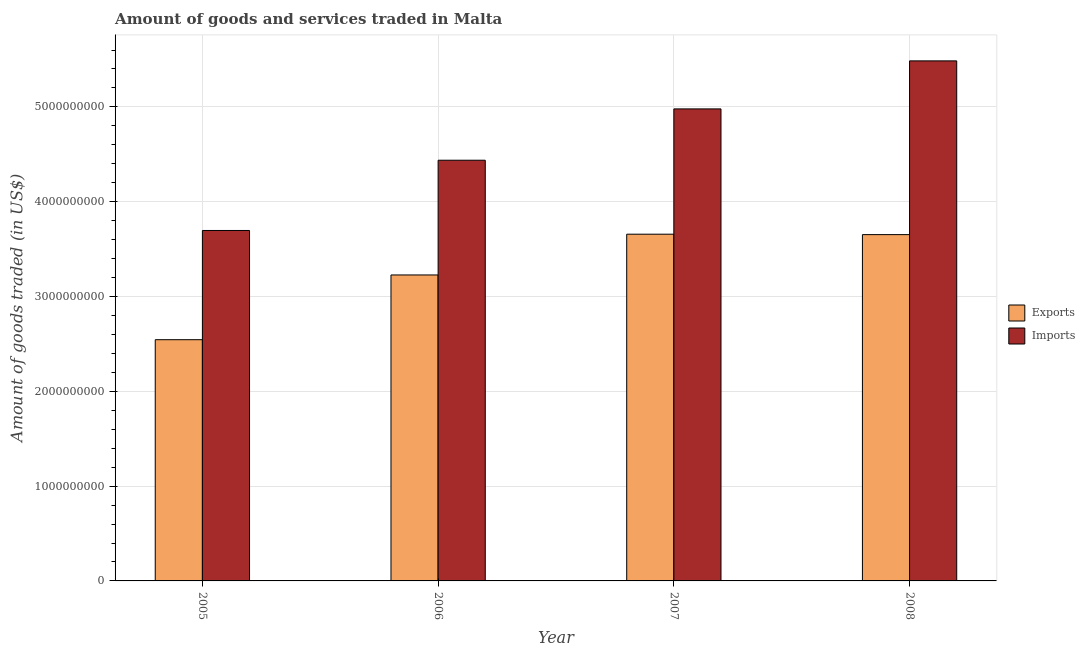How many groups of bars are there?
Your answer should be very brief. 4. Are the number of bars per tick equal to the number of legend labels?
Ensure brevity in your answer.  Yes. Are the number of bars on each tick of the X-axis equal?
Offer a very short reply. Yes. How many bars are there on the 1st tick from the left?
Your answer should be compact. 2. What is the amount of goods exported in 2006?
Ensure brevity in your answer.  3.23e+09. Across all years, what is the maximum amount of goods exported?
Provide a succinct answer. 3.66e+09. Across all years, what is the minimum amount of goods exported?
Offer a very short reply. 2.54e+09. In which year was the amount of goods imported maximum?
Make the answer very short. 2008. In which year was the amount of goods imported minimum?
Give a very brief answer. 2005. What is the total amount of goods exported in the graph?
Offer a terse response. 1.31e+1. What is the difference between the amount of goods imported in 2007 and that in 2008?
Your answer should be compact. -5.07e+08. What is the difference between the amount of goods exported in 2005 and the amount of goods imported in 2008?
Make the answer very short. -1.11e+09. What is the average amount of goods imported per year?
Offer a terse response. 4.65e+09. In the year 2005, what is the difference between the amount of goods exported and amount of goods imported?
Provide a succinct answer. 0. In how many years, is the amount of goods imported greater than 3800000000 US$?
Your answer should be compact. 3. What is the ratio of the amount of goods imported in 2005 to that in 2008?
Your answer should be very brief. 0.67. Is the difference between the amount of goods imported in 2005 and 2006 greater than the difference between the amount of goods exported in 2005 and 2006?
Your answer should be compact. No. What is the difference between the highest and the second highest amount of goods exported?
Offer a very short reply. 4.45e+06. What is the difference between the highest and the lowest amount of goods imported?
Your answer should be compact. 1.79e+09. In how many years, is the amount of goods imported greater than the average amount of goods imported taken over all years?
Keep it short and to the point. 2. Is the sum of the amount of goods exported in 2005 and 2007 greater than the maximum amount of goods imported across all years?
Ensure brevity in your answer.  Yes. What does the 1st bar from the left in 2005 represents?
Make the answer very short. Exports. What does the 1st bar from the right in 2008 represents?
Ensure brevity in your answer.  Imports. How many bars are there?
Your answer should be very brief. 8. Are the values on the major ticks of Y-axis written in scientific E-notation?
Ensure brevity in your answer.  No. Does the graph contain any zero values?
Your answer should be compact. No. Does the graph contain grids?
Make the answer very short. Yes. Where does the legend appear in the graph?
Ensure brevity in your answer.  Center right. What is the title of the graph?
Provide a short and direct response. Amount of goods and services traded in Malta. What is the label or title of the Y-axis?
Ensure brevity in your answer.  Amount of goods traded (in US$). What is the Amount of goods traded (in US$) in Exports in 2005?
Keep it short and to the point. 2.54e+09. What is the Amount of goods traded (in US$) in Imports in 2005?
Ensure brevity in your answer.  3.70e+09. What is the Amount of goods traded (in US$) in Exports in 2006?
Make the answer very short. 3.23e+09. What is the Amount of goods traded (in US$) in Imports in 2006?
Provide a succinct answer. 4.44e+09. What is the Amount of goods traded (in US$) in Exports in 2007?
Keep it short and to the point. 3.66e+09. What is the Amount of goods traded (in US$) of Imports in 2007?
Offer a very short reply. 4.98e+09. What is the Amount of goods traded (in US$) in Exports in 2008?
Provide a short and direct response. 3.65e+09. What is the Amount of goods traded (in US$) in Imports in 2008?
Provide a short and direct response. 5.49e+09. Across all years, what is the maximum Amount of goods traded (in US$) of Exports?
Offer a very short reply. 3.66e+09. Across all years, what is the maximum Amount of goods traded (in US$) of Imports?
Make the answer very short. 5.49e+09. Across all years, what is the minimum Amount of goods traded (in US$) of Exports?
Make the answer very short. 2.54e+09. Across all years, what is the minimum Amount of goods traded (in US$) of Imports?
Your response must be concise. 3.70e+09. What is the total Amount of goods traded (in US$) in Exports in the graph?
Provide a short and direct response. 1.31e+1. What is the total Amount of goods traded (in US$) of Imports in the graph?
Provide a short and direct response. 1.86e+1. What is the difference between the Amount of goods traded (in US$) in Exports in 2005 and that in 2006?
Your response must be concise. -6.83e+08. What is the difference between the Amount of goods traded (in US$) of Imports in 2005 and that in 2006?
Make the answer very short. -7.41e+08. What is the difference between the Amount of goods traded (in US$) in Exports in 2005 and that in 2007?
Keep it short and to the point. -1.11e+09. What is the difference between the Amount of goods traded (in US$) in Imports in 2005 and that in 2007?
Your answer should be compact. -1.28e+09. What is the difference between the Amount of goods traded (in US$) in Exports in 2005 and that in 2008?
Keep it short and to the point. -1.11e+09. What is the difference between the Amount of goods traded (in US$) in Imports in 2005 and that in 2008?
Your answer should be very brief. -1.79e+09. What is the difference between the Amount of goods traded (in US$) of Exports in 2006 and that in 2007?
Provide a short and direct response. -4.30e+08. What is the difference between the Amount of goods traded (in US$) in Imports in 2006 and that in 2007?
Make the answer very short. -5.41e+08. What is the difference between the Amount of goods traded (in US$) of Exports in 2006 and that in 2008?
Provide a succinct answer. -4.25e+08. What is the difference between the Amount of goods traded (in US$) of Imports in 2006 and that in 2008?
Offer a very short reply. -1.05e+09. What is the difference between the Amount of goods traded (in US$) of Exports in 2007 and that in 2008?
Your answer should be very brief. 4.45e+06. What is the difference between the Amount of goods traded (in US$) of Imports in 2007 and that in 2008?
Keep it short and to the point. -5.07e+08. What is the difference between the Amount of goods traded (in US$) of Exports in 2005 and the Amount of goods traded (in US$) of Imports in 2006?
Your answer should be compact. -1.89e+09. What is the difference between the Amount of goods traded (in US$) in Exports in 2005 and the Amount of goods traded (in US$) in Imports in 2007?
Provide a short and direct response. -2.43e+09. What is the difference between the Amount of goods traded (in US$) in Exports in 2005 and the Amount of goods traded (in US$) in Imports in 2008?
Keep it short and to the point. -2.94e+09. What is the difference between the Amount of goods traded (in US$) of Exports in 2006 and the Amount of goods traded (in US$) of Imports in 2007?
Ensure brevity in your answer.  -1.75e+09. What is the difference between the Amount of goods traded (in US$) in Exports in 2006 and the Amount of goods traded (in US$) in Imports in 2008?
Your response must be concise. -2.26e+09. What is the difference between the Amount of goods traded (in US$) in Exports in 2007 and the Amount of goods traded (in US$) in Imports in 2008?
Provide a succinct answer. -1.83e+09. What is the average Amount of goods traded (in US$) in Exports per year?
Ensure brevity in your answer.  3.27e+09. What is the average Amount of goods traded (in US$) in Imports per year?
Your response must be concise. 4.65e+09. In the year 2005, what is the difference between the Amount of goods traded (in US$) of Exports and Amount of goods traded (in US$) of Imports?
Your answer should be compact. -1.15e+09. In the year 2006, what is the difference between the Amount of goods traded (in US$) of Exports and Amount of goods traded (in US$) of Imports?
Offer a terse response. -1.21e+09. In the year 2007, what is the difference between the Amount of goods traded (in US$) of Exports and Amount of goods traded (in US$) of Imports?
Offer a very short reply. -1.32e+09. In the year 2008, what is the difference between the Amount of goods traded (in US$) of Exports and Amount of goods traded (in US$) of Imports?
Your response must be concise. -1.83e+09. What is the ratio of the Amount of goods traded (in US$) in Exports in 2005 to that in 2006?
Give a very brief answer. 0.79. What is the ratio of the Amount of goods traded (in US$) of Imports in 2005 to that in 2006?
Offer a terse response. 0.83. What is the ratio of the Amount of goods traded (in US$) of Exports in 2005 to that in 2007?
Your response must be concise. 0.7. What is the ratio of the Amount of goods traded (in US$) of Imports in 2005 to that in 2007?
Your answer should be very brief. 0.74. What is the ratio of the Amount of goods traded (in US$) of Exports in 2005 to that in 2008?
Keep it short and to the point. 0.7. What is the ratio of the Amount of goods traded (in US$) in Imports in 2005 to that in 2008?
Offer a very short reply. 0.67. What is the ratio of the Amount of goods traded (in US$) of Exports in 2006 to that in 2007?
Offer a terse response. 0.88. What is the ratio of the Amount of goods traded (in US$) in Imports in 2006 to that in 2007?
Ensure brevity in your answer.  0.89. What is the ratio of the Amount of goods traded (in US$) in Exports in 2006 to that in 2008?
Your answer should be very brief. 0.88. What is the ratio of the Amount of goods traded (in US$) in Imports in 2006 to that in 2008?
Offer a very short reply. 0.81. What is the ratio of the Amount of goods traded (in US$) of Exports in 2007 to that in 2008?
Your response must be concise. 1. What is the ratio of the Amount of goods traded (in US$) in Imports in 2007 to that in 2008?
Give a very brief answer. 0.91. What is the difference between the highest and the second highest Amount of goods traded (in US$) of Exports?
Ensure brevity in your answer.  4.45e+06. What is the difference between the highest and the second highest Amount of goods traded (in US$) of Imports?
Ensure brevity in your answer.  5.07e+08. What is the difference between the highest and the lowest Amount of goods traded (in US$) in Exports?
Offer a very short reply. 1.11e+09. What is the difference between the highest and the lowest Amount of goods traded (in US$) of Imports?
Your response must be concise. 1.79e+09. 